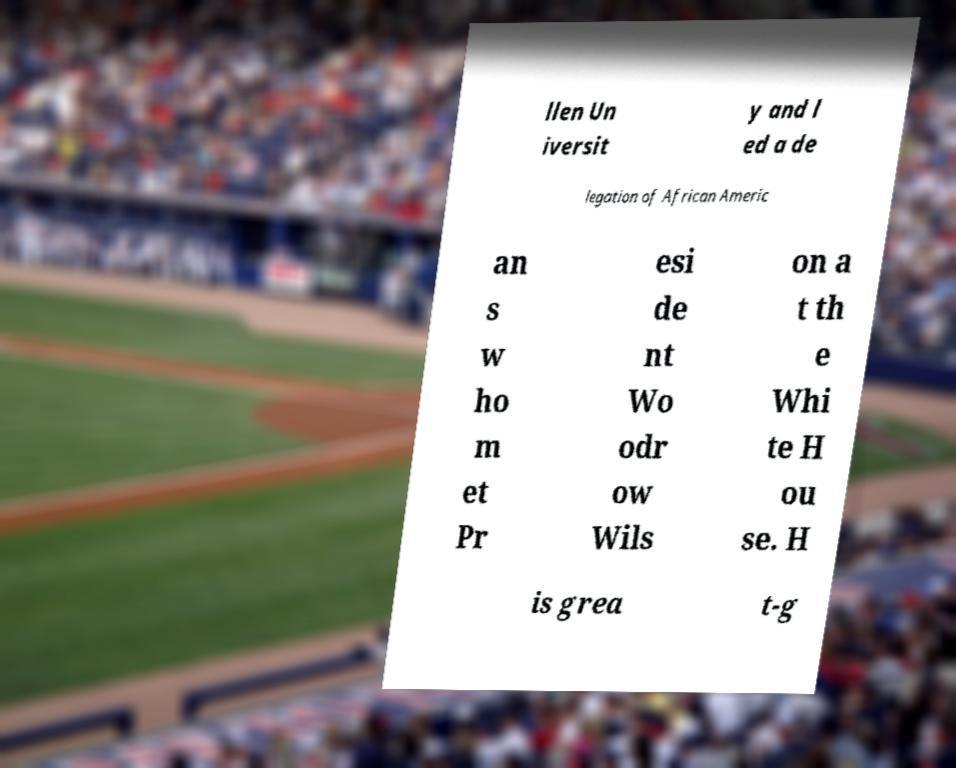There's text embedded in this image that I need extracted. Can you transcribe it verbatim? llen Un iversit y and l ed a de legation of African Americ an s w ho m et Pr esi de nt Wo odr ow Wils on a t th e Whi te H ou se. H is grea t-g 